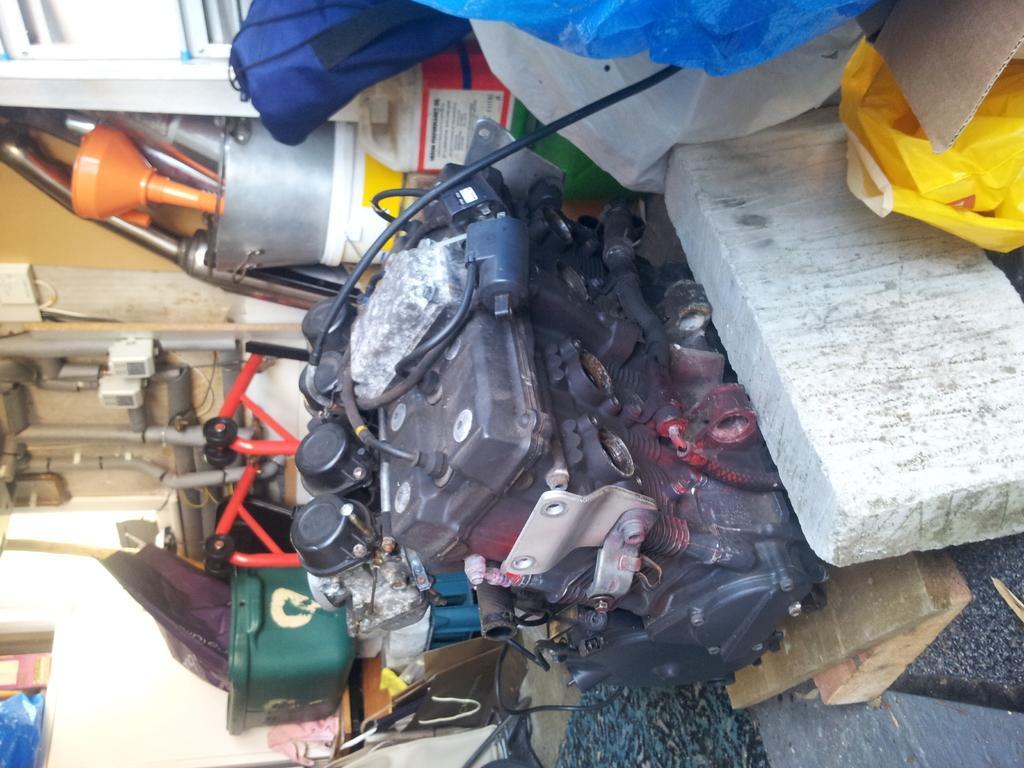How would you summarize this image in a sentence or two? In the middle of the picture, we see the engine of the vehicle. Beside that, we see a white color block, carpet and the wooden planks. At the top, we see the plastic bags in white, yellow and blue cover. At the bottom, we see a green color box is placed on the table. Beside that, we see a chair and some other objects are placed under the table. On the left side, we see buckets, funnel and some objects. In the left bottom, we see a white wall. 